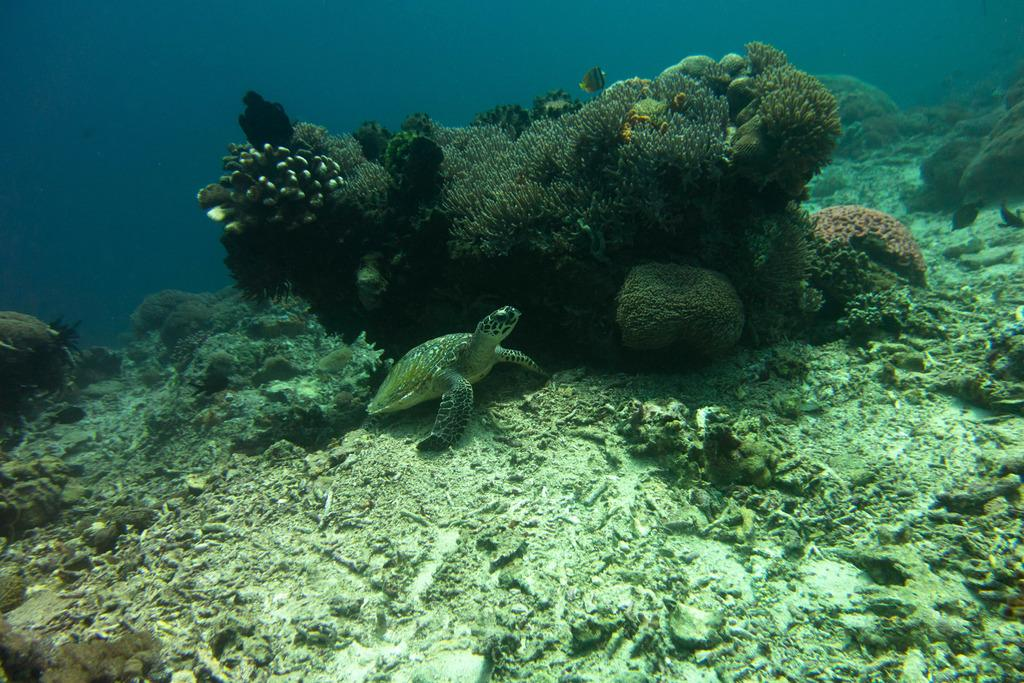What animal is in the image? There is a tortoise in the image. Where is the tortoise located? The tortoise is in the water. What can be seen in the background of the image? There are sea plants in the background of the image. What type of pipe is being used by the tortoise in the image? There is no pipe present in the image; the tortoise is in the water among sea plants. 